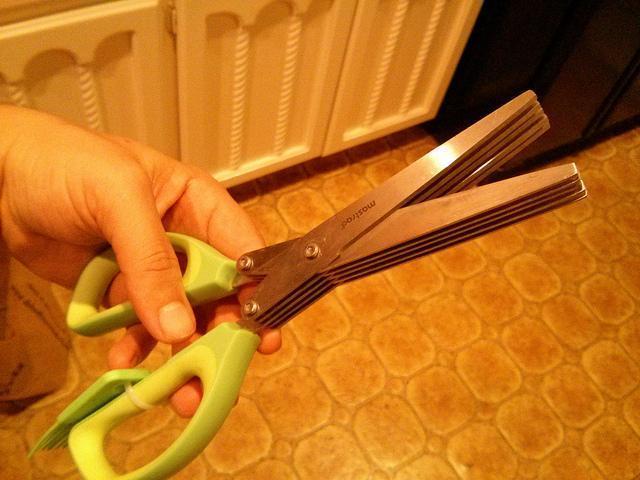Does the caption "The scissors is at the left side of the person." correctly depict the image?
Answer yes or no. No. Is "The scissors is alongside the person." an appropriate description for the image?
Answer yes or no. No. 